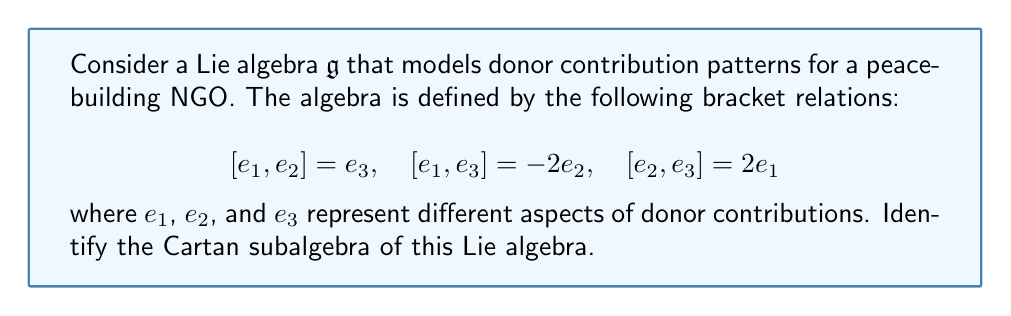Can you answer this question? To identify the Cartan subalgebra of this Lie algebra, we need to follow these steps:

1) Recall that a Cartan subalgebra is a maximal abelian subalgebra consisting of semisimple elements.

2) First, let's check if any of the basis elements commute with all others:

   $[e_1, e_2] = e_3 \neq 0$
   $[e_1, e_3] = -2e_2 \neq 0$
   $[e_2, e_3] = 2e_1 \neq 0$

   None of the basis elements commute with all others, so none of them alone form the Cartan subalgebra.

3) Next, let's consider linear combinations of the basis elements. Let $h = ae_1 + be_2 + ce_3$ be a general element of $\mathfrak{g}$.

4) For $h$ to be in the Cartan subalgebra, it must commute with itself and be semisimple. Let's compute $[h,e_i]$ for each $i$:

   $[h,e_1] = [ae_1 + be_2 + ce_3, e_1] = b[e_2,e_1] + c[e_3,e_1] = -be_3 + 2ce_2$
   $[h,e_2] = [ae_1 + be_2 + ce_3, e_2] = a[e_1,e_2] + c[e_3,e_2] = ae_3 - 2ce_1$
   $[h,e_3] = [ae_1 + be_2 + ce_3, e_3] = a[e_1,e_3] + b[e_2,e_3] = -2ae_2 + 2be_1$

5) For $h$ to be in the Cartan subalgebra, all these must be scalar multiples of $h$. This is only possible if $a = b = c = 0$.

6) Therefore, the only element that commutes with everything is the zero element.

7) The zero subalgebra is not a Cartan subalgebra because it's not maximal.

8) This Lie algebra is actually isomorphic to $\mathfrak{so}(3)$, which is known to have no non-zero Cartan subalgebra.
Answer: The Cartan subalgebra of this Lie algebra is $\{0\}$, i.e., it contains only the zero element. 